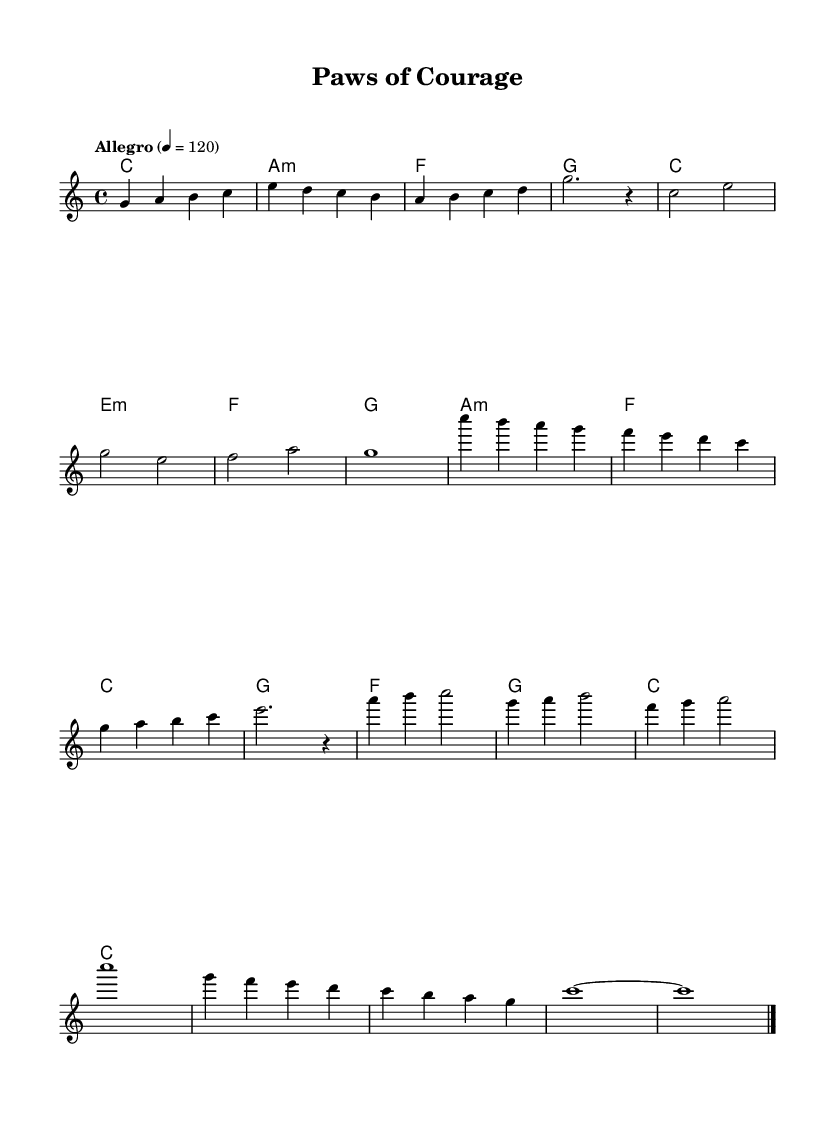What is the key signature of this music? The key signature is C major, which is indicated by the absence of any sharps or flats in the key signature area.
Answer: C major What is the time signature of this music? The time signature is 4/4, as indicated at the beginning of the score. It specifies that there are four beats per measure and the quarter note receives one beat.
Answer: 4/4 What is the tempo marking of this piece? The tempo marking is "Allegro," and it is specified with a metronome marking of 120, indicating a fast pace.
Answer: Allegro What type of chord is played at the beginning of the piece? The piece begins with a C major chord. The first chord shown indicates a root position C major, which is denoted by the letter C.
Answer: C How many measures are in the chorus section? The chorus section consists of four measures as shown in the sheet music. This can be confirmed by counting the measures labeled in that section of the score.
Answer: 4 Which section of the music has the longest note value? The longest note value occurs in the outro, where the final note is a whole note (c1), lasting for four beats. This is observed in the last measure, where a whole note is indicated.
Answer: Whole note Which part of the music features a bridge? The bridge section appears after the verse and before the outro, and it's explicitly labeled as "Bridge." This is further validated by its distinct thematic material.
Answer: Bridge 